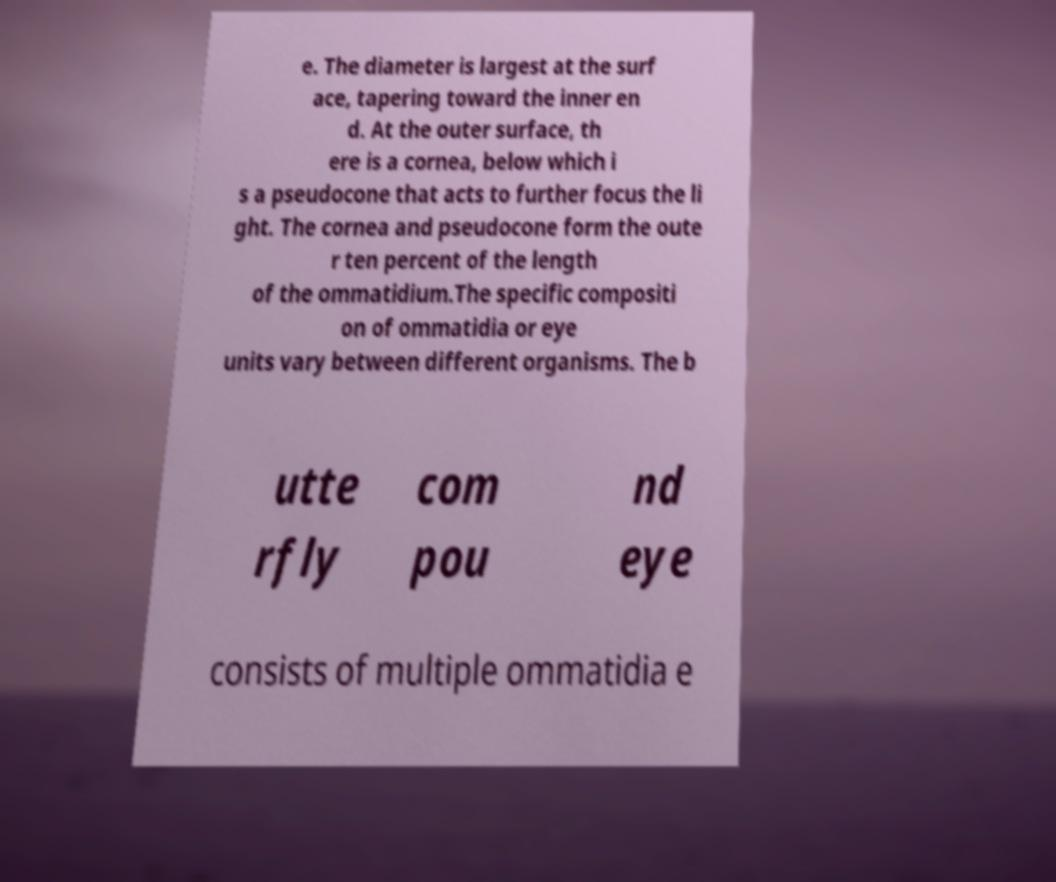Can you read and provide the text displayed in the image?This photo seems to have some interesting text. Can you extract and type it out for me? e. The diameter is largest at the surf ace, tapering toward the inner en d. At the outer surface, th ere is a cornea, below which i s a pseudocone that acts to further focus the li ght. The cornea and pseudocone form the oute r ten percent of the length of the ommatidium.The specific compositi on of ommatidia or eye units vary between different organisms. The b utte rfly com pou nd eye consists of multiple ommatidia e 